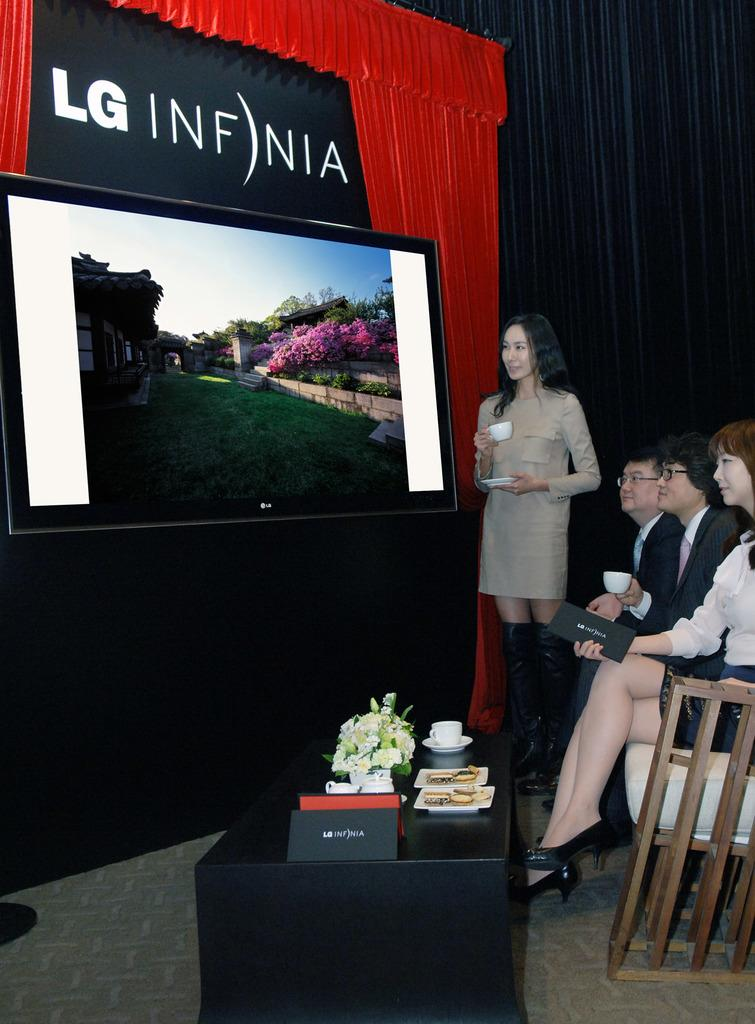<image>
Summarize the visual content of the image. A television is on display showing the new LG Infnia 